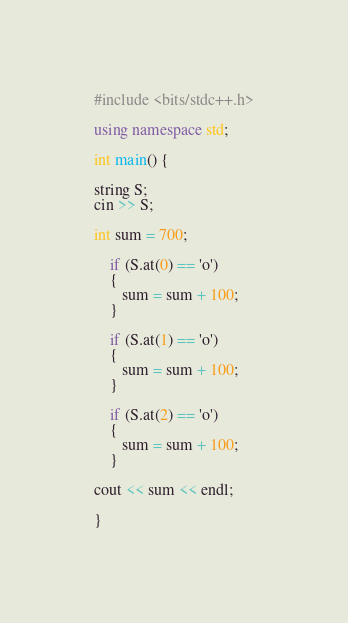Convert code to text. <code><loc_0><loc_0><loc_500><loc_500><_C++_>#include <bits/stdc++.h>

using namespace std;
 
int main() {

string S;
cin >> S;

int sum = 700;

    if (S.at(0) == 'o')
    {
       sum = sum + 100;
    }

    if (S.at(1) == 'o')
    {
       sum = sum + 100;
    }

    if (S.at(2) == 'o')
    {
       sum = sum + 100;
    }

cout << sum << endl;   

}</code> 